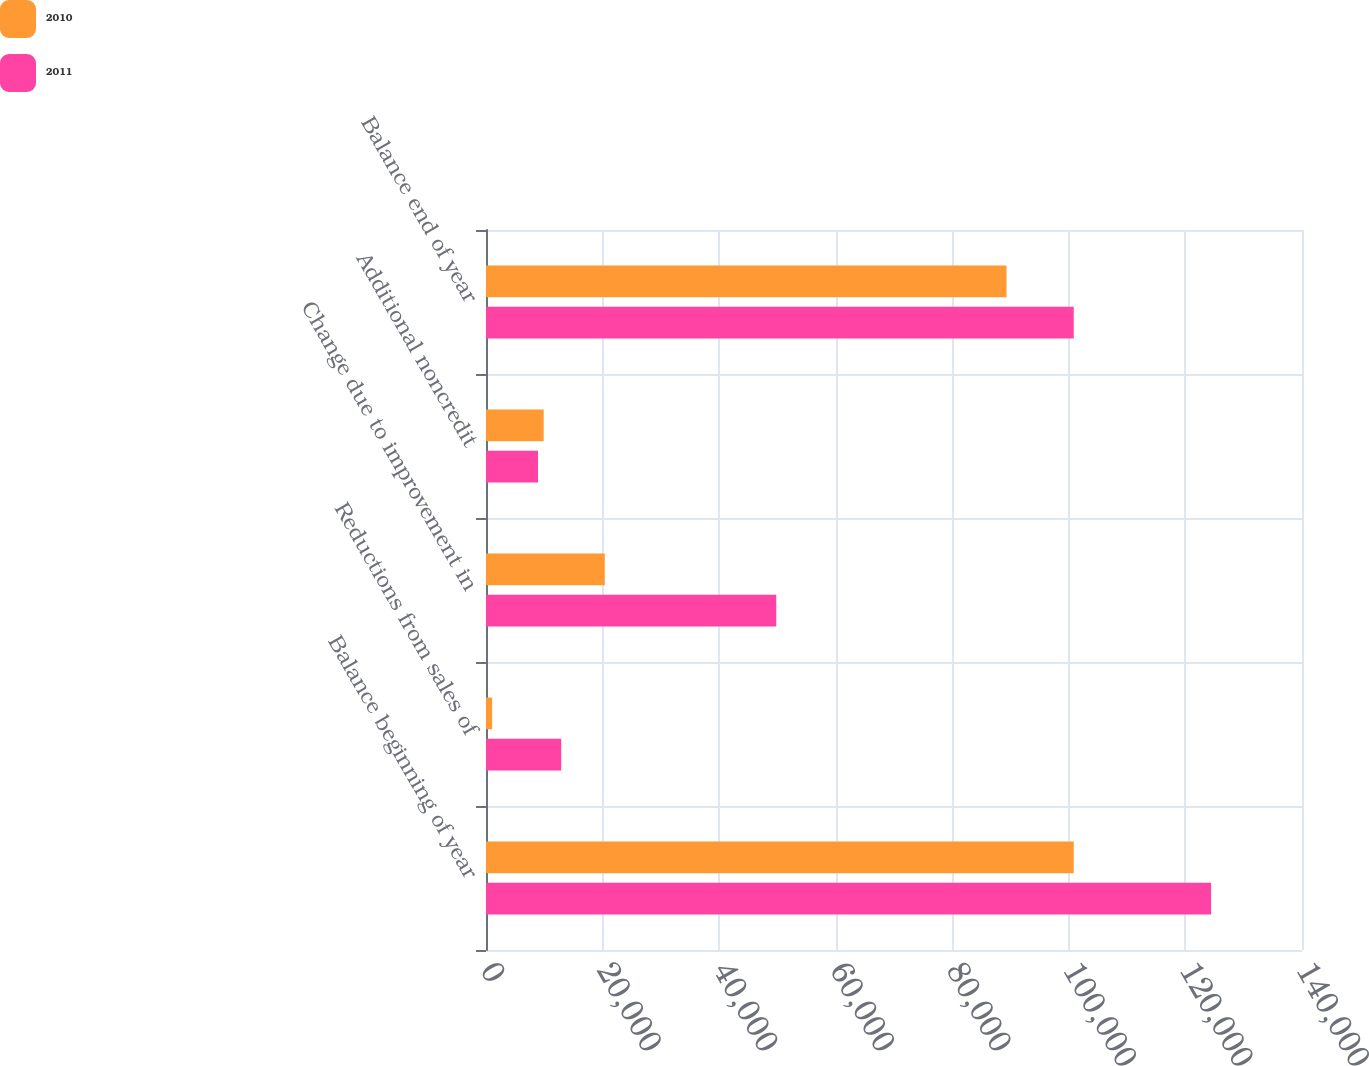Convert chart. <chart><loc_0><loc_0><loc_500><loc_500><stacked_bar_chart><ecel><fcel>Balance beginning of year<fcel>Reductions from sales of<fcel>Change due to improvement in<fcel>Additional noncredit<fcel>Balance end of year<nl><fcel>2010<fcel>100838<fcel>1053<fcel>20379<fcel>9895<fcel>89301<nl><fcel>2011<fcel>124408<fcel>12907<fcel>49802<fcel>8924<fcel>100838<nl></chart> 